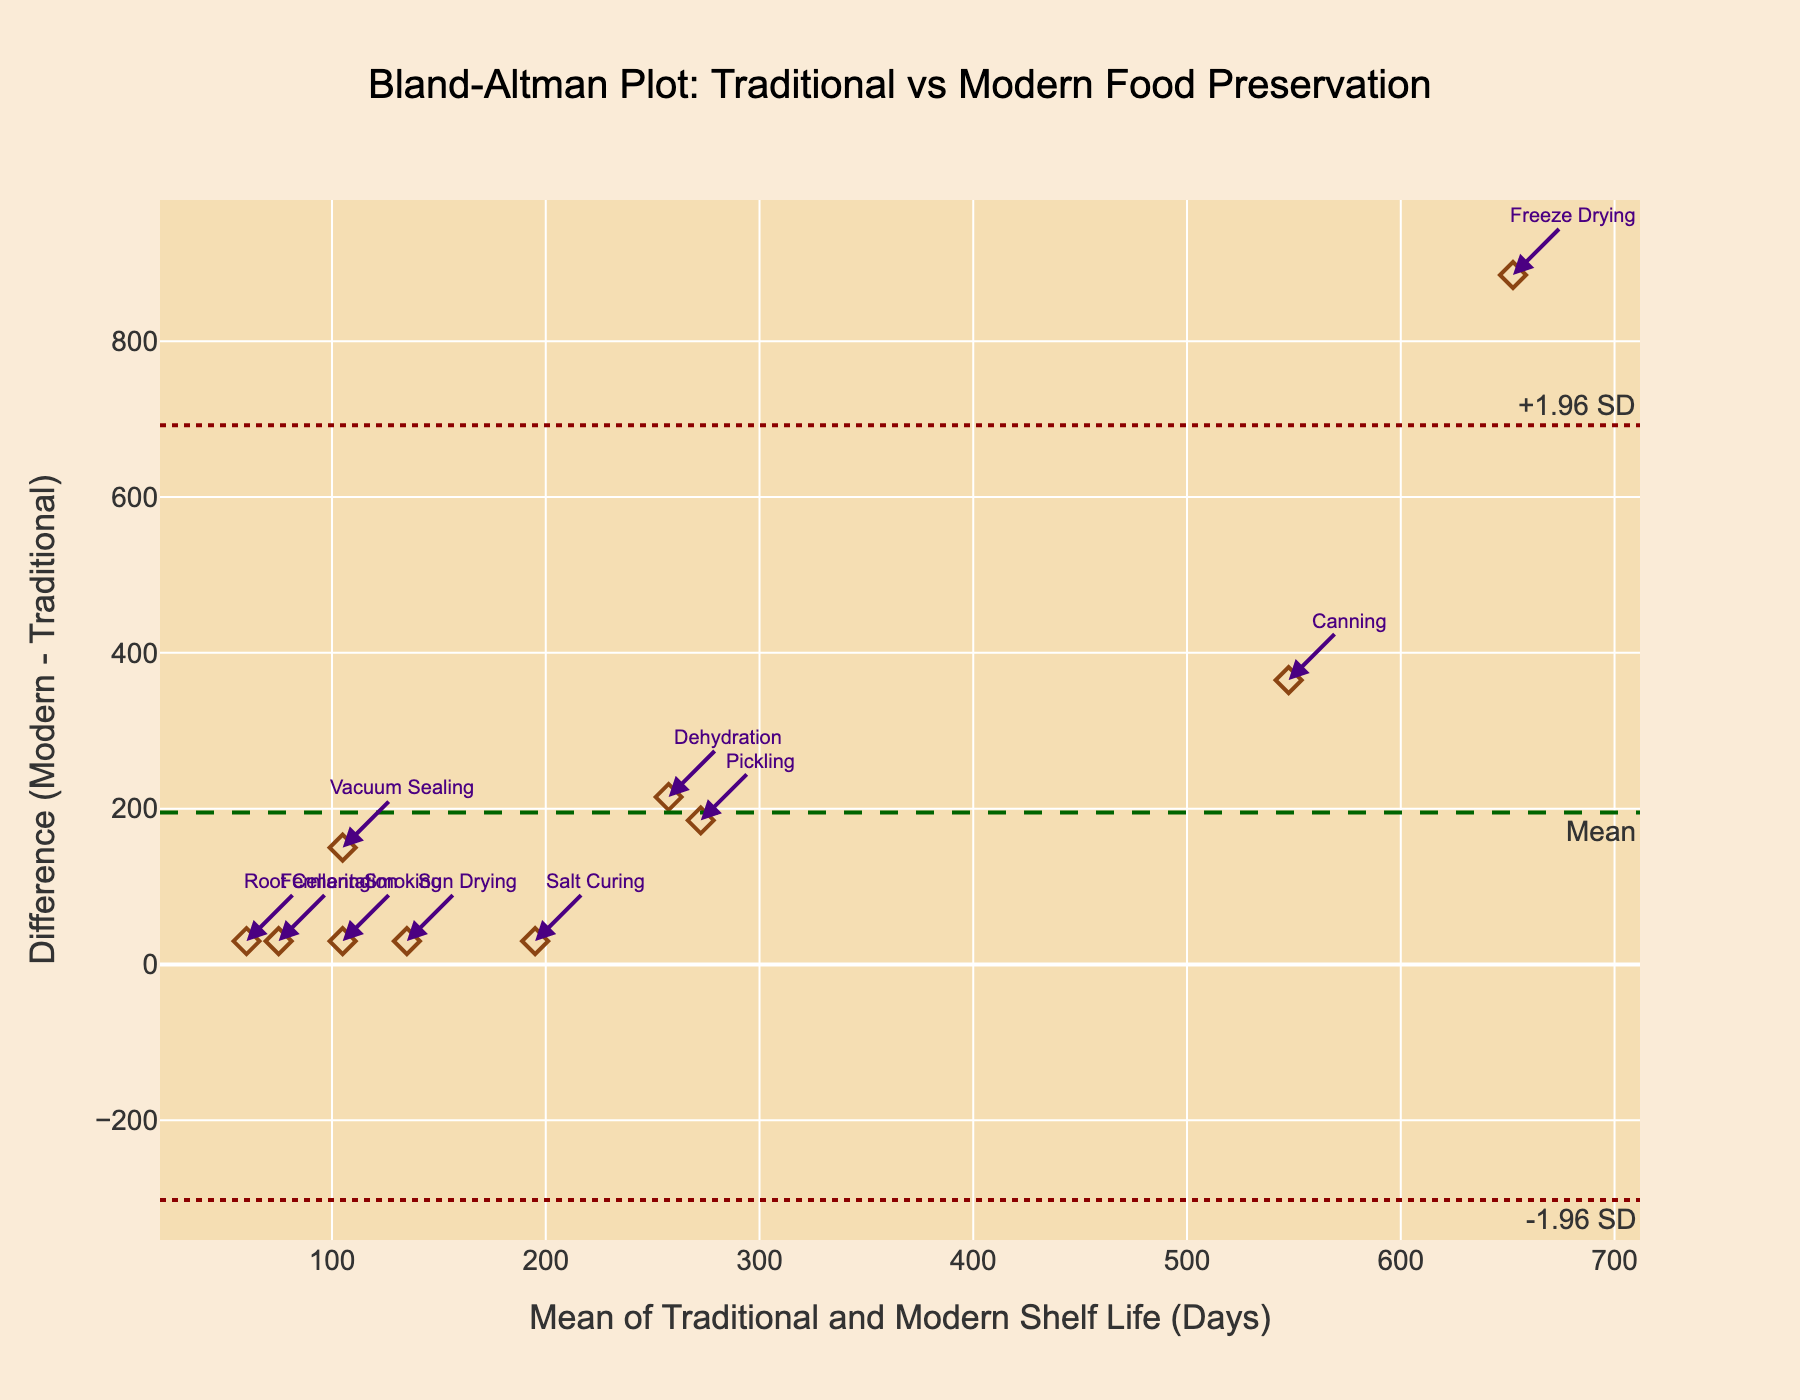what is the title of the plot? The title of the plot is usually displayed at the top center of the chart and provides a summary of what the chart is about. In this case, the title can be found above the plot.
Answer: Bland-Altman Plot: Traditional vs Modern Food Preservation how many food preservation methods are compared in the figure? To determine the number of data points, observe the number of individual labels annotated in the plot. Each label corresponds to a different method.
Answer: 10 On the plot, what does the x-axis represent? The x-axis is labeled to provide context to the data represented horizontally. Here, it shows "Mean of Traditional and Modern Shelf Life (Days)"
Answer: Mean of Traditional and Modern Shelf Life (Days) what is the mean difference between traditional and modern shelf life preservation methods? The mean difference (md) is a horizontal line denoted as "Mean" on the plot. It represents the average difference between traditional and modern shelf life across all methods.
Answer: About 226 days What do the dashed and dotted lines on the plot represent? The dashed line marks the mean difference, while the dotted lines indicate the limits of agreement, which are mean difference plus or minus 1.96 standard deviations. These boundaries help in understanding the variability of the differences.
Answer: Mean difference and ±1.96 SD which method shows the largest difference in shelf life? The method with the largest difference in shelf life will have the highest vertical deviation from the mean difference line. Identify the data point farthest away from the mean difference line on the y-axis.
Answer: Vacuum Sealing Which method shows the smallest difference in shelf life? The method with the smallest difference will have the data point closest to the mean difference line (or on the mean difference line) in the plot.
Answer: Salt Curing for which method is the mean shelf life (average of traditional and modern) the highest? Identify the data point that is farthest to the right on the x-axis, as the x-axis represents the mean of traditional and modern shelf life.
Answer: Canning Are there any methods where the traditional method has a longer shelf life than the modern method? Look for any data points below the zero line in the difference (y-axis). These indicate where the modern shelf life is less than the traditional shelf life.
Answer: No which method has the greatest absolute variability difference compared to the mean difference? Calculate the absolute difference between the method's difference value and the mean difference, then compare which one has the highest value. This is the point farthest in either direction from the mean line.
Answer: Vacuum Sealing 